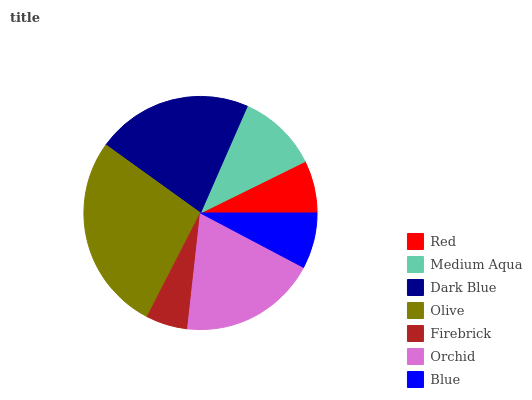Is Firebrick the minimum?
Answer yes or no. Yes. Is Olive the maximum?
Answer yes or no. Yes. Is Medium Aqua the minimum?
Answer yes or no. No. Is Medium Aqua the maximum?
Answer yes or no. No. Is Medium Aqua greater than Red?
Answer yes or no. Yes. Is Red less than Medium Aqua?
Answer yes or no. Yes. Is Red greater than Medium Aqua?
Answer yes or no. No. Is Medium Aqua less than Red?
Answer yes or no. No. Is Medium Aqua the high median?
Answer yes or no. Yes. Is Medium Aqua the low median?
Answer yes or no. Yes. Is Firebrick the high median?
Answer yes or no. No. Is Blue the low median?
Answer yes or no. No. 